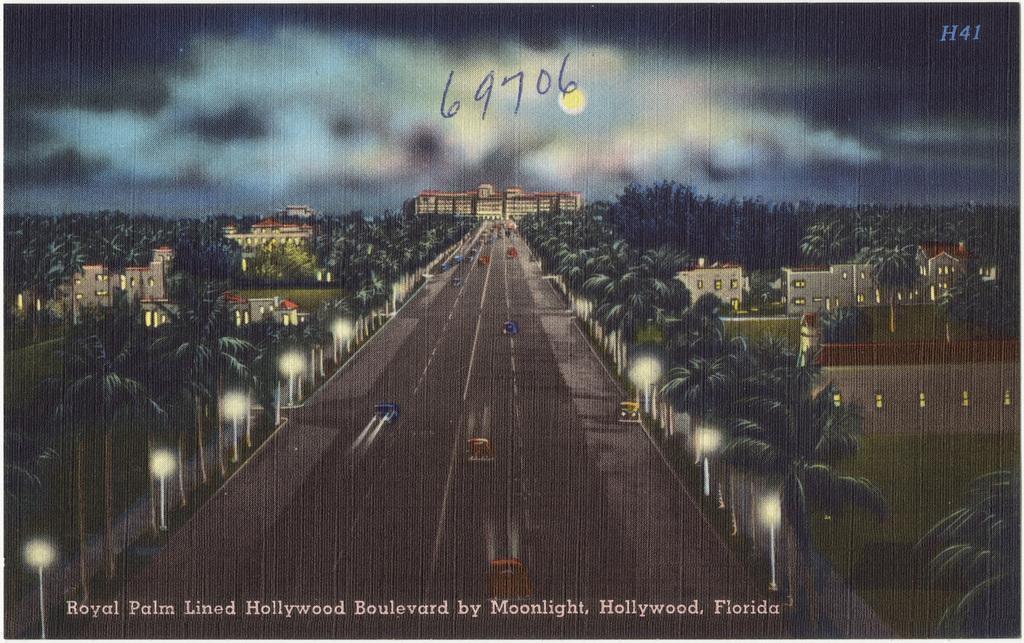In one or two sentences, can you explain what this image depicts? This is a painting and here we can see trees, buildings, lights and some vehicles on the road. At the bottom, there is a text written. 